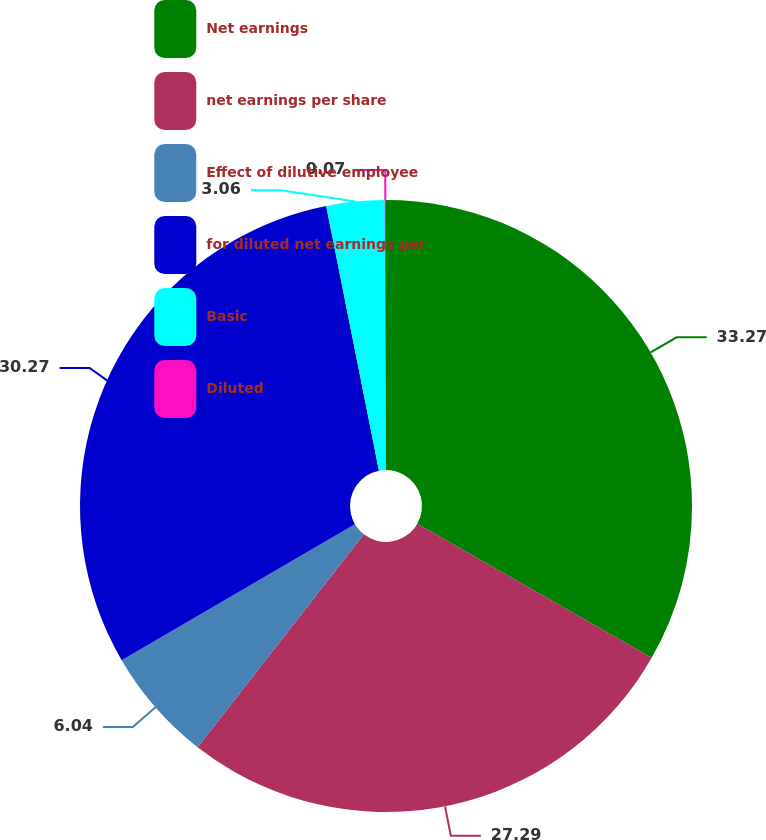Convert chart. <chart><loc_0><loc_0><loc_500><loc_500><pie_chart><fcel>Net earnings<fcel>net earnings per share<fcel>Effect of dilutive employee<fcel>for diluted net earnings per<fcel>Basic<fcel>Diluted<nl><fcel>33.26%<fcel>27.29%<fcel>6.04%<fcel>30.27%<fcel>3.06%<fcel>0.07%<nl></chart> 